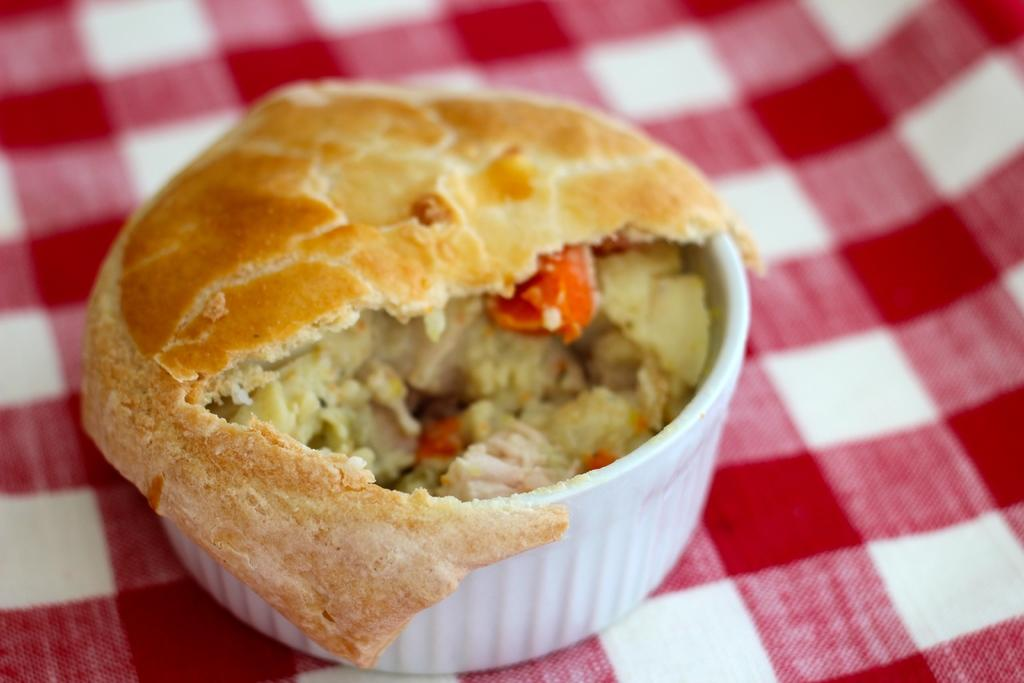What is the color of the cup in the image? The cup in the image is white. What is inside the cup? There is a food item in the cup. Can you describe the mat under the cup? The mat under the cup has red and white colors. What is the rate of steam coming out of the cup in the image? There is no steam coming out of the cup in the image. 